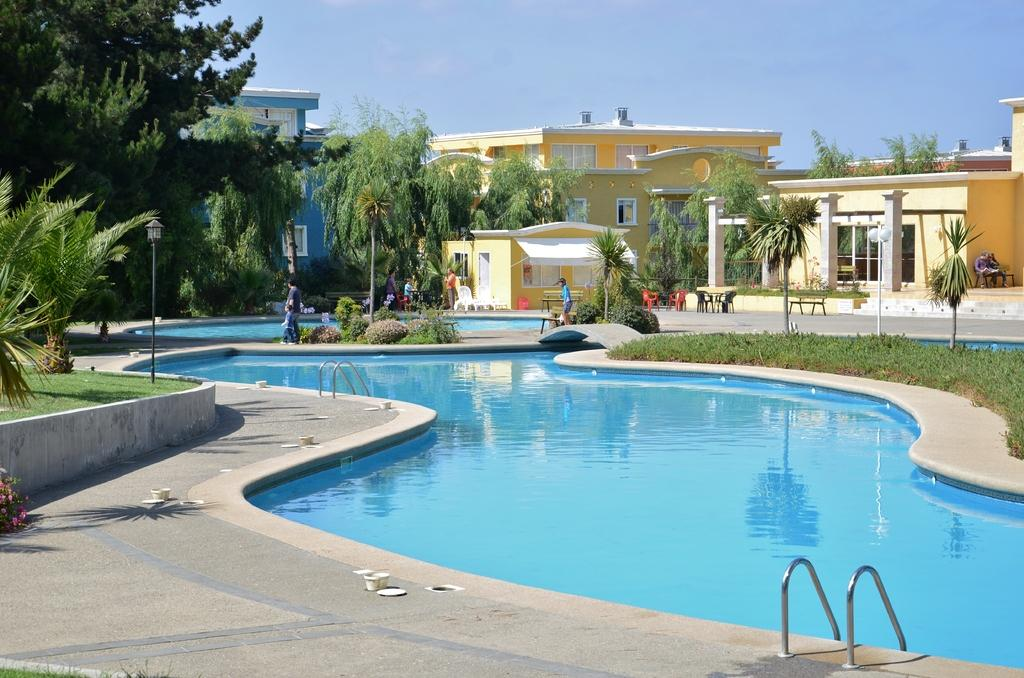What is the main feature in the center of the image? There is a swimming pool in the center of the image. Can you describe the people in the image? There are people in the image, but their specific actions or activities are not mentioned in the facts. What type of furniture is present in the image? There are benches, tables, and chairs in the image. What other structures can be seen in the image? There are poles, trees, and buildings in the image. What is visible in the background of the image? The sky is visible in the image. What type of market can be seen in the image? There is no market present in the image. How low are the chairs in the image? The facts do not provide information about the height of the chairs, so we cannot determine how low they are. 